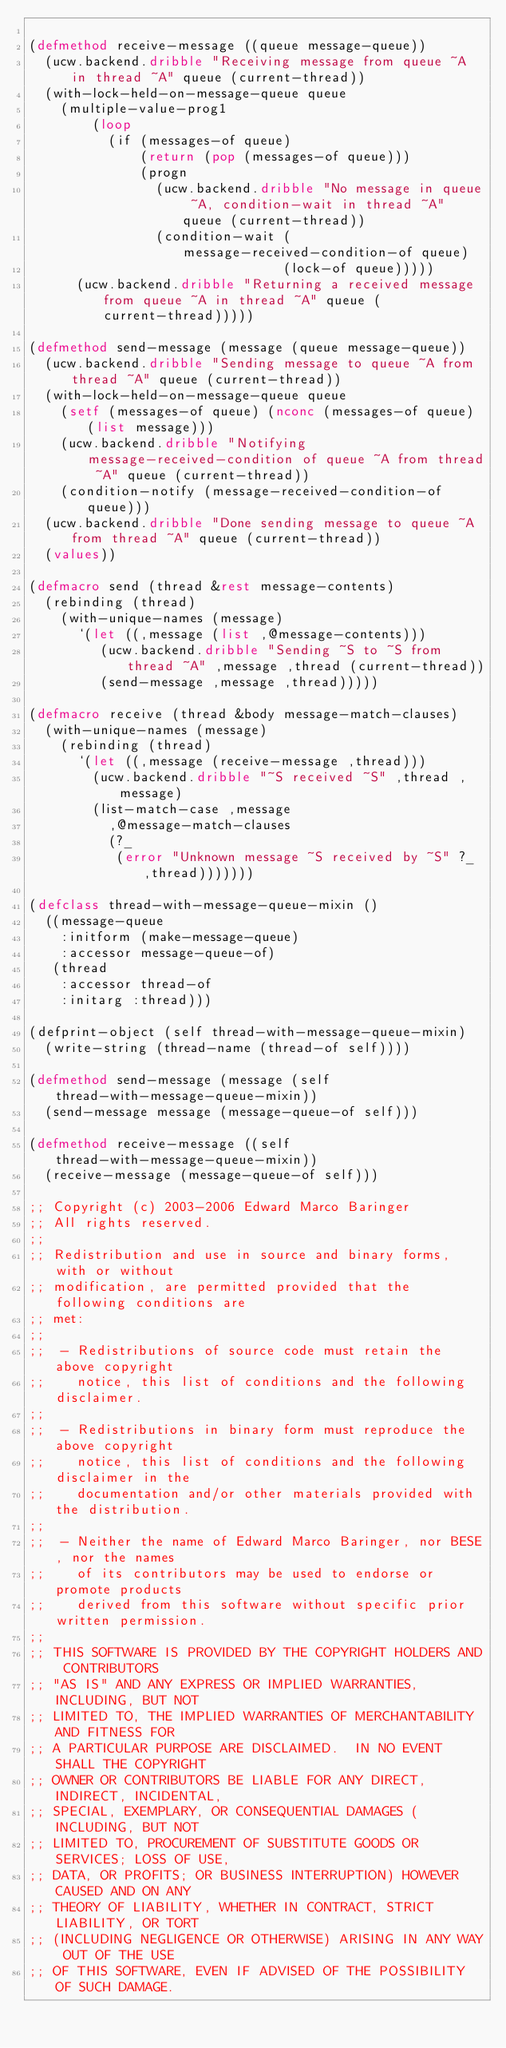Convert code to text. <code><loc_0><loc_0><loc_500><loc_500><_Lisp_>
(defmethod receive-message ((queue message-queue))
  (ucw.backend.dribble "Receiving message from queue ~A in thread ~A" queue (current-thread))
  (with-lock-held-on-message-queue queue
    (multiple-value-prog1
        (loop
          (if (messages-of queue)
              (return (pop (messages-of queue)))
              (progn
                (ucw.backend.dribble "No message in queue ~A, condition-wait in thread ~A" queue (current-thread))
                (condition-wait (message-received-condition-of queue)
                                (lock-of queue)))))
      (ucw.backend.dribble "Returning a received message from queue ~A in thread ~A" queue (current-thread)))))

(defmethod send-message (message (queue message-queue))
  (ucw.backend.dribble "Sending message to queue ~A from thread ~A" queue (current-thread))
  (with-lock-held-on-message-queue queue
    (setf (messages-of queue) (nconc (messages-of queue) (list message)))
    (ucw.backend.dribble "Notifying message-received-condition of queue ~A from thread ~A" queue (current-thread))
    (condition-notify (message-received-condition-of queue)))
  (ucw.backend.dribble "Done sending message to queue ~A from thread ~A" queue (current-thread))
  (values))

(defmacro send (thread &rest message-contents)
  (rebinding (thread)
    (with-unique-names (message)
      `(let ((,message (list ,@message-contents)))
         (ucw.backend.dribble "Sending ~S to ~S from thread ~A" ,message ,thread (current-thread))
         (send-message ,message ,thread)))))

(defmacro receive (thread &body message-match-clauses)
  (with-unique-names (message)
    (rebinding (thread)
      `(let ((,message (receive-message ,thread)))
        (ucw.backend.dribble "~S received ~S" ,thread ,message)
        (list-match-case ,message
          ,@message-match-clauses
          (?_
           (error "Unknown message ~S received by ~S" ?_ ,thread)))))))

(defclass thread-with-message-queue-mixin ()
  ((message-queue
    :initform (make-message-queue)
    :accessor message-queue-of)
   (thread
    :accessor thread-of
    :initarg :thread)))

(defprint-object (self thread-with-message-queue-mixin)
  (write-string (thread-name (thread-of self))))

(defmethod send-message (message (self thread-with-message-queue-mixin))
  (send-message message (message-queue-of self)))

(defmethod receive-message ((self thread-with-message-queue-mixin))
  (receive-message (message-queue-of self)))

;; Copyright (c) 2003-2006 Edward Marco Baringer
;; All rights reserved.
;;
;; Redistribution and use in source and binary forms, with or without
;; modification, are permitted provided that the following conditions are
;; met:
;;
;;  - Redistributions of source code must retain the above copyright
;;    notice, this list of conditions and the following disclaimer.
;;
;;  - Redistributions in binary form must reproduce the above copyright
;;    notice, this list of conditions and the following disclaimer in the
;;    documentation and/or other materials provided with the distribution.
;;
;;  - Neither the name of Edward Marco Baringer, nor BESE, nor the names
;;    of its contributors may be used to endorse or promote products
;;    derived from this software without specific prior written permission.
;;
;; THIS SOFTWARE IS PROVIDED BY THE COPYRIGHT HOLDERS AND CONTRIBUTORS
;; "AS IS" AND ANY EXPRESS OR IMPLIED WARRANTIES, INCLUDING, BUT NOT
;; LIMITED TO, THE IMPLIED WARRANTIES OF MERCHANTABILITY AND FITNESS FOR
;; A PARTICULAR PURPOSE ARE DISCLAIMED.  IN NO EVENT SHALL THE COPYRIGHT
;; OWNER OR CONTRIBUTORS BE LIABLE FOR ANY DIRECT, INDIRECT, INCIDENTAL,
;; SPECIAL, EXEMPLARY, OR CONSEQUENTIAL DAMAGES (INCLUDING, BUT NOT
;; LIMITED TO, PROCUREMENT OF SUBSTITUTE GOODS OR SERVICES; LOSS OF USE,
;; DATA, OR PROFITS; OR BUSINESS INTERRUPTION) HOWEVER CAUSED AND ON ANY
;; THEORY OF LIABILITY, WHETHER IN CONTRACT, STRICT LIABILITY, OR TORT
;; (INCLUDING NEGLIGENCE OR OTHERWISE) ARISING IN ANY WAY OUT OF THE USE
;; OF THIS SOFTWARE, EVEN IF ADVISED OF THE POSSIBILITY OF SUCH DAMAGE.
</code> 